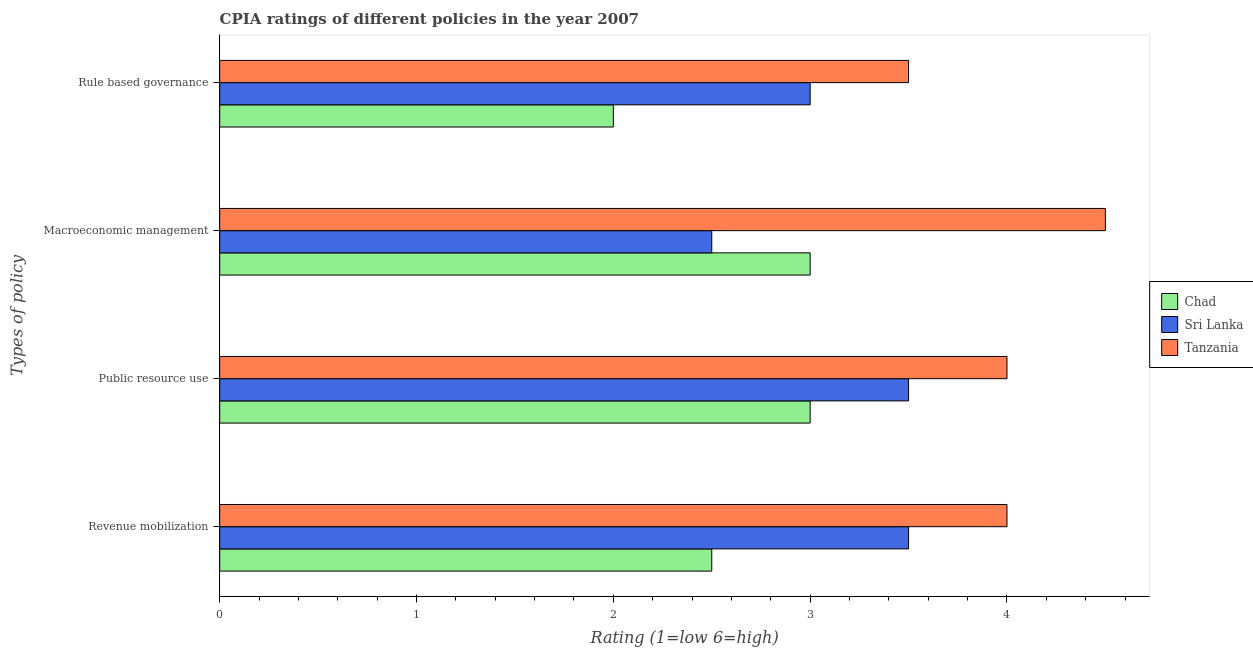How many groups of bars are there?
Provide a short and direct response. 4. Are the number of bars per tick equal to the number of legend labels?
Provide a short and direct response. Yes. How many bars are there on the 3rd tick from the top?
Make the answer very short. 3. How many bars are there on the 2nd tick from the bottom?
Keep it short and to the point. 3. What is the label of the 3rd group of bars from the top?
Offer a terse response. Public resource use. What is the cpia rating of revenue mobilization in Sri Lanka?
Make the answer very short. 3.5. Across all countries, what is the maximum cpia rating of macroeconomic management?
Provide a succinct answer. 4.5. In which country was the cpia rating of macroeconomic management maximum?
Keep it short and to the point. Tanzania. In which country was the cpia rating of revenue mobilization minimum?
Provide a short and direct response. Chad. What is the average cpia rating of revenue mobilization per country?
Your answer should be very brief. 3.33. In how many countries, is the cpia rating of public resource use greater than 3.8 ?
Give a very brief answer. 1. What is the ratio of the cpia rating of revenue mobilization in Tanzania to that in Sri Lanka?
Offer a very short reply. 1.14. Is the cpia rating of revenue mobilization in Chad less than that in Sri Lanka?
Keep it short and to the point. Yes. What is the difference between the highest and the second highest cpia rating of public resource use?
Provide a succinct answer. 0.5. What is the difference between the highest and the lowest cpia rating of public resource use?
Provide a succinct answer. 1. Is it the case that in every country, the sum of the cpia rating of macroeconomic management and cpia rating of rule based governance is greater than the sum of cpia rating of public resource use and cpia rating of revenue mobilization?
Your answer should be compact. No. What does the 2nd bar from the top in Macroeconomic management represents?
Offer a very short reply. Sri Lanka. What does the 2nd bar from the bottom in Public resource use represents?
Make the answer very short. Sri Lanka. How many bars are there?
Keep it short and to the point. 12. Does the graph contain grids?
Keep it short and to the point. No. Where does the legend appear in the graph?
Your answer should be very brief. Center right. How many legend labels are there?
Provide a short and direct response. 3. How are the legend labels stacked?
Provide a short and direct response. Vertical. What is the title of the graph?
Provide a short and direct response. CPIA ratings of different policies in the year 2007. What is the label or title of the Y-axis?
Offer a terse response. Types of policy. What is the Rating (1=low 6=high) in Chad in Revenue mobilization?
Give a very brief answer. 2.5. What is the Rating (1=low 6=high) of Sri Lanka in Revenue mobilization?
Offer a very short reply. 3.5. What is the Rating (1=low 6=high) of Tanzania in Public resource use?
Your response must be concise. 4. What is the Rating (1=low 6=high) of Chad in Macroeconomic management?
Your answer should be compact. 3. What is the Rating (1=low 6=high) of Tanzania in Macroeconomic management?
Provide a short and direct response. 4.5. What is the Rating (1=low 6=high) in Sri Lanka in Rule based governance?
Offer a terse response. 3. What is the Rating (1=low 6=high) of Tanzania in Rule based governance?
Make the answer very short. 3.5. Across all Types of policy, what is the maximum Rating (1=low 6=high) in Tanzania?
Your answer should be compact. 4.5. What is the total Rating (1=low 6=high) in Chad in the graph?
Keep it short and to the point. 10.5. What is the total Rating (1=low 6=high) in Tanzania in the graph?
Provide a succinct answer. 16. What is the difference between the Rating (1=low 6=high) in Chad in Revenue mobilization and that in Public resource use?
Ensure brevity in your answer.  -0.5. What is the difference between the Rating (1=low 6=high) of Sri Lanka in Revenue mobilization and that in Public resource use?
Make the answer very short. 0. What is the difference between the Rating (1=low 6=high) in Sri Lanka in Revenue mobilization and that in Macroeconomic management?
Your answer should be compact. 1. What is the difference between the Rating (1=low 6=high) in Sri Lanka in Revenue mobilization and that in Rule based governance?
Your response must be concise. 0.5. What is the difference between the Rating (1=low 6=high) of Sri Lanka in Public resource use and that in Macroeconomic management?
Provide a short and direct response. 1. What is the difference between the Rating (1=low 6=high) in Tanzania in Public resource use and that in Macroeconomic management?
Offer a very short reply. -0.5. What is the difference between the Rating (1=low 6=high) in Sri Lanka in Macroeconomic management and that in Rule based governance?
Provide a short and direct response. -0.5. What is the difference between the Rating (1=low 6=high) in Tanzania in Macroeconomic management and that in Rule based governance?
Offer a very short reply. 1. What is the difference between the Rating (1=low 6=high) of Chad in Revenue mobilization and the Rating (1=low 6=high) of Tanzania in Public resource use?
Give a very brief answer. -1.5. What is the difference between the Rating (1=low 6=high) in Sri Lanka in Revenue mobilization and the Rating (1=low 6=high) in Tanzania in Public resource use?
Your answer should be compact. -0.5. What is the difference between the Rating (1=low 6=high) of Chad in Revenue mobilization and the Rating (1=low 6=high) of Sri Lanka in Rule based governance?
Provide a short and direct response. -0.5. What is the difference between the Rating (1=low 6=high) in Chad in Revenue mobilization and the Rating (1=low 6=high) in Tanzania in Rule based governance?
Give a very brief answer. -1. What is the difference between the Rating (1=low 6=high) in Chad in Public resource use and the Rating (1=low 6=high) in Sri Lanka in Macroeconomic management?
Give a very brief answer. 0.5. What is the difference between the Rating (1=low 6=high) in Chad in Public resource use and the Rating (1=low 6=high) in Tanzania in Macroeconomic management?
Keep it short and to the point. -1.5. What is the difference between the Rating (1=low 6=high) in Sri Lanka in Public resource use and the Rating (1=low 6=high) in Tanzania in Macroeconomic management?
Your response must be concise. -1. What is the difference between the Rating (1=low 6=high) of Sri Lanka in Public resource use and the Rating (1=low 6=high) of Tanzania in Rule based governance?
Offer a terse response. 0. What is the difference between the Rating (1=low 6=high) of Chad in Macroeconomic management and the Rating (1=low 6=high) of Sri Lanka in Rule based governance?
Make the answer very short. 0. What is the difference between the Rating (1=low 6=high) in Chad in Macroeconomic management and the Rating (1=low 6=high) in Tanzania in Rule based governance?
Provide a short and direct response. -0.5. What is the average Rating (1=low 6=high) of Chad per Types of policy?
Give a very brief answer. 2.62. What is the average Rating (1=low 6=high) of Sri Lanka per Types of policy?
Offer a terse response. 3.12. What is the average Rating (1=low 6=high) in Tanzania per Types of policy?
Your answer should be compact. 4. What is the difference between the Rating (1=low 6=high) of Chad and Rating (1=low 6=high) of Tanzania in Revenue mobilization?
Provide a short and direct response. -1.5. What is the difference between the Rating (1=low 6=high) in Chad and Rating (1=low 6=high) in Sri Lanka in Public resource use?
Ensure brevity in your answer.  -0.5. What is the difference between the Rating (1=low 6=high) in Chad and Rating (1=low 6=high) in Sri Lanka in Macroeconomic management?
Your answer should be very brief. 0.5. What is the difference between the Rating (1=low 6=high) of Sri Lanka and Rating (1=low 6=high) of Tanzania in Macroeconomic management?
Offer a terse response. -2. What is the difference between the Rating (1=low 6=high) of Chad and Rating (1=low 6=high) of Tanzania in Rule based governance?
Ensure brevity in your answer.  -1.5. What is the ratio of the Rating (1=low 6=high) in Tanzania in Revenue mobilization to that in Public resource use?
Provide a short and direct response. 1. What is the ratio of the Rating (1=low 6=high) in Chad in Revenue mobilization to that in Macroeconomic management?
Your answer should be very brief. 0.83. What is the ratio of the Rating (1=low 6=high) in Tanzania in Revenue mobilization to that in Macroeconomic management?
Keep it short and to the point. 0.89. What is the ratio of the Rating (1=low 6=high) of Chad in Revenue mobilization to that in Rule based governance?
Your answer should be compact. 1.25. What is the ratio of the Rating (1=low 6=high) of Tanzania in Revenue mobilization to that in Rule based governance?
Provide a succinct answer. 1.14. What is the ratio of the Rating (1=low 6=high) of Chad in Public resource use to that in Macroeconomic management?
Give a very brief answer. 1. What is the ratio of the Rating (1=low 6=high) of Sri Lanka in Public resource use to that in Rule based governance?
Your answer should be very brief. 1.17. What is the ratio of the Rating (1=low 6=high) of Tanzania in Public resource use to that in Rule based governance?
Ensure brevity in your answer.  1.14. What is the ratio of the Rating (1=low 6=high) of Sri Lanka in Macroeconomic management to that in Rule based governance?
Offer a terse response. 0.83. What is the ratio of the Rating (1=low 6=high) in Tanzania in Macroeconomic management to that in Rule based governance?
Offer a very short reply. 1.29. What is the difference between the highest and the second highest Rating (1=low 6=high) in Chad?
Offer a very short reply. 0. What is the difference between the highest and the second highest Rating (1=low 6=high) of Sri Lanka?
Provide a succinct answer. 0. What is the difference between the highest and the second highest Rating (1=low 6=high) in Tanzania?
Provide a succinct answer. 0.5. What is the difference between the highest and the lowest Rating (1=low 6=high) in Sri Lanka?
Offer a very short reply. 1. 